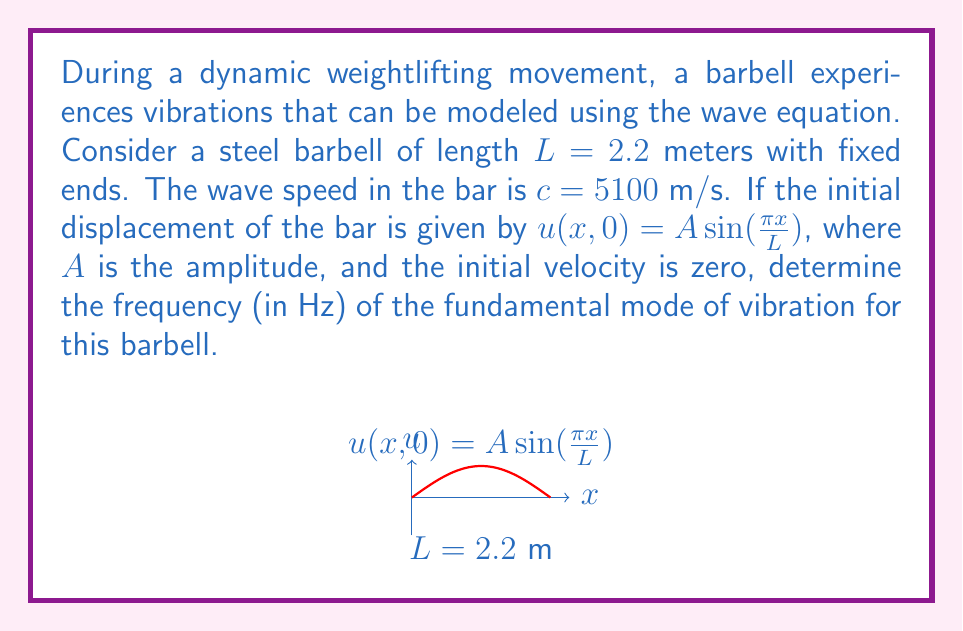Can you answer this question? Let's approach this step-by-step:

1) The wave equation for a vibrating string or bar is given by:

   $$\frac{\partial^2 u}{\partial t^2} = c^2 \frac{\partial^2 u}{\partial x^2}$$

2) For fixed ends, the boundary conditions are:
   
   $u(0,t) = u(L,t) = 0$ for all $t$

3) The general solution for this problem is of the form:

   $$u(x,t) = \sum_{n=1}^{\infty} (A_n \cos(\omega_n t) + B_n \sin(\omega_n t)) \sin(\frac{n\pi x}{L})$$

4) Given the initial conditions, we can see that our solution corresponds to the fundamental mode ($n=1$) with $B_1 = 0$. So we're interested in $\omega_1$.

5) The relationship between $\omega_n$ and $n$ is:

   $$\omega_n = \frac{n\pi c}{L}$$

6) For the fundamental mode ($n=1$):

   $$\omega_1 = \frac{\pi c}{L}$$

7) Substituting the given values:

   $$\omega_1 = \frac{\pi \cdot 5100}{2.2} = 7277.27 \text{ rad/s}$$

8) To convert angular frequency to frequency in Hz, we use:

   $$f = \frac{\omega}{2\pi}$$

9) Therefore:

   $$f = \frac{7277.27}{2\pi} = 1158.31 \text{ Hz}$$
Answer: 1158.31 Hz 